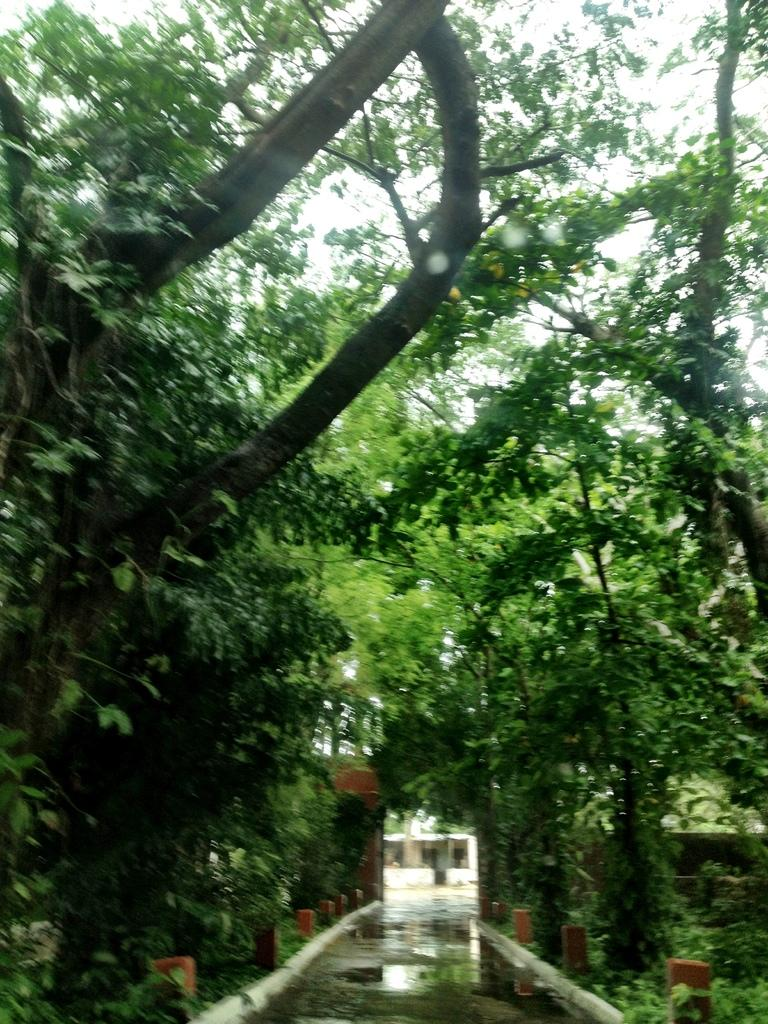What can be seen in the foreground of the image? There is a path in the foreground of the image. What objects are located near the path? There are bollard-like objects on either side of the path. What type of vegetation is present near the path? There are trees on either side of the path. What is visible at the top of the image? The sky is visible at the top of the image. What type of ornament is hanging from the trees in the image? There are no ornaments hanging from the trees in the image; only trees and bollard-like objects are present. Can you tell me how many knives are visible in the image? There are no knives visible in the image. 